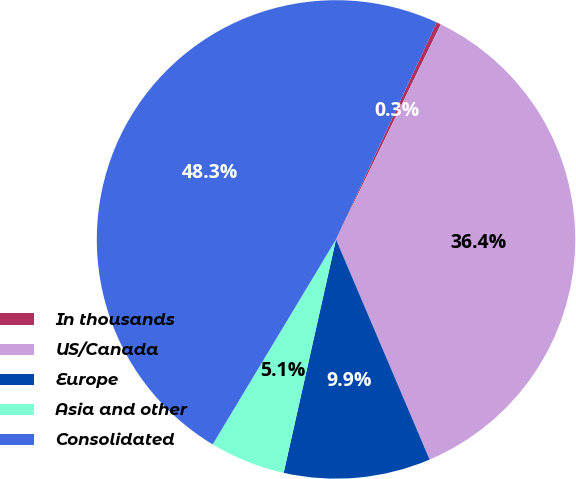<chart> <loc_0><loc_0><loc_500><loc_500><pie_chart><fcel>In thousands<fcel>US/Canada<fcel>Europe<fcel>Asia and other<fcel>Consolidated<nl><fcel>0.31%<fcel>36.39%<fcel>9.91%<fcel>5.11%<fcel>48.29%<nl></chart> 